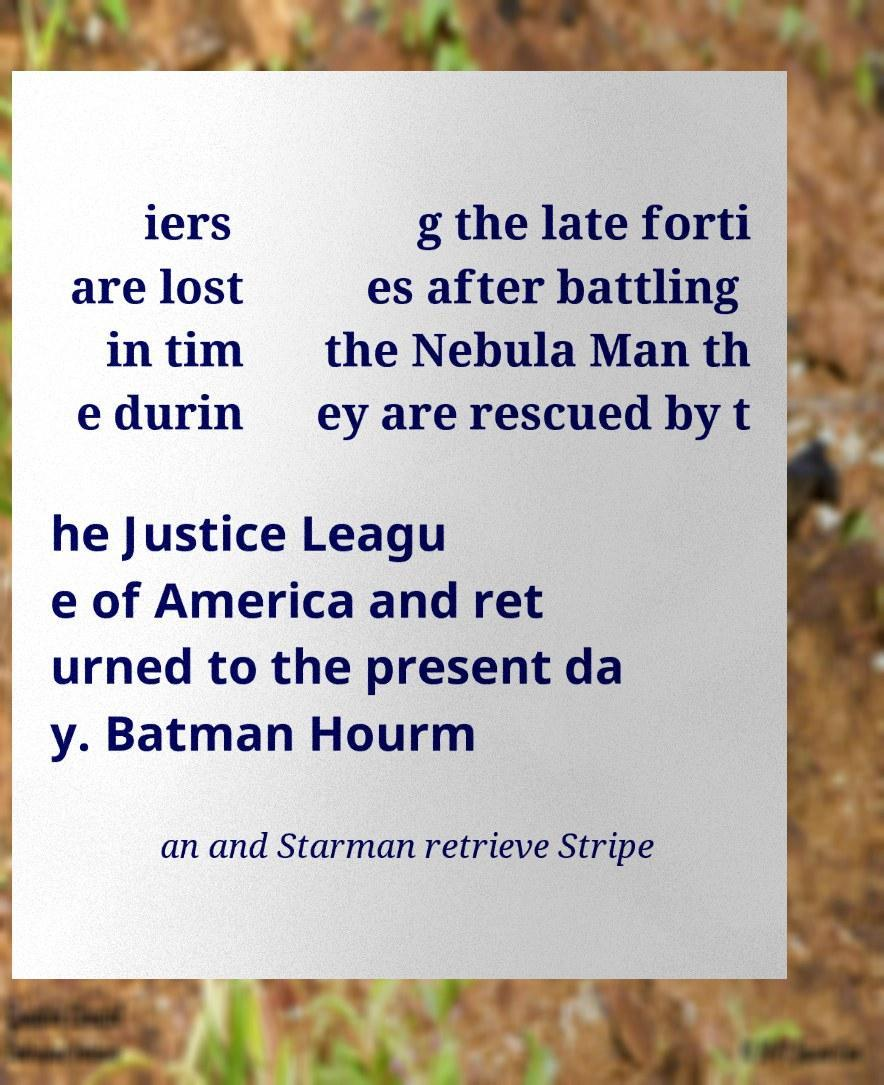Could you assist in decoding the text presented in this image and type it out clearly? iers are lost in tim e durin g the late forti es after battling the Nebula Man th ey are rescued by t he Justice Leagu e of America and ret urned to the present da y. Batman Hourm an and Starman retrieve Stripe 